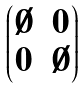<formula> <loc_0><loc_0><loc_500><loc_500>\begin{pmatrix} \emptyset & 0 \\ 0 & \emptyset \end{pmatrix}</formula> 